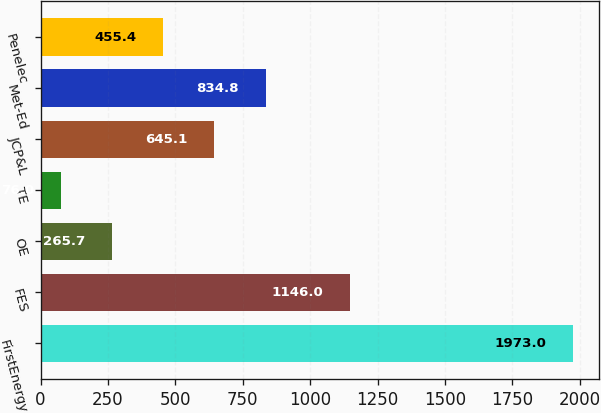<chart> <loc_0><loc_0><loc_500><loc_500><bar_chart><fcel>FirstEnergy<fcel>FES<fcel>OE<fcel>TE<fcel>JCP&L<fcel>Met-Ed<fcel>Penelec<nl><fcel>1973<fcel>1146<fcel>265.7<fcel>76<fcel>645.1<fcel>834.8<fcel>455.4<nl></chart> 